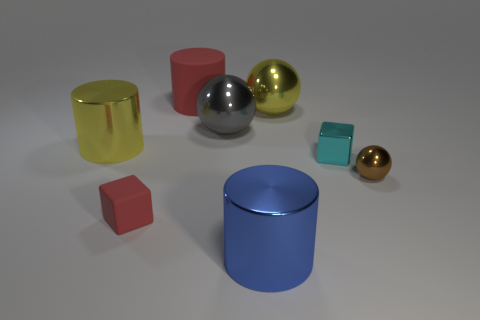There is a large yellow shiny thing that is on the left side of the large metal thing that is to the right of the large cylinder that is right of the big rubber cylinder; what shape is it?
Your answer should be compact. Cylinder. Is the color of the large matte thing the same as the matte block?
Provide a succinct answer. Yes. What material is the red thing on the right side of the red rubber thing that is left of the red cylinder?
Offer a terse response. Rubber. There is a small brown object; what shape is it?
Provide a succinct answer. Sphere. What is the material of the big red thing that is the same shape as the blue metal object?
Offer a very short reply. Rubber. How many other brown cylinders have the same size as the rubber cylinder?
Provide a succinct answer. 0. Are there any large gray metallic balls on the right side of the metallic cylinder to the right of the large gray ball?
Make the answer very short. No. How many brown objects are cylinders or spheres?
Offer a terse response. 1. The tiny shiny ball has what color?
Your answer should be compact. Brown. What is the size of the gray ball that is made of the same material as the cyan block?
Keep it short and to the point. Large. 